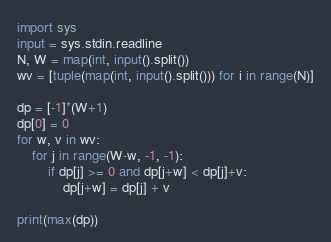<code> <loc_0><loc_0><loc_500><loc_500><_Python_>import sys
input = sys.stdin.readline
N, W = map(int, input().split())
wv = [tuple(map(int, input().split())) for i in range(N)]
 
dp = [-1]*(W+1)
dp[0] = 0
for w, v in wv:
    for j in range(W-w, -1, -1):
        if dp[j] >= 0 and dp[j+w] < dp[j]+v:
            dp[j+w] = dp[j] + v
 
print(max(dp))</code> 